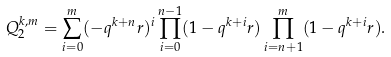Convert formula to latex. <formula><loc_0><loc_0><loc_500><loc_500>Q _ { 2 } ^ { k , m } = \sum _ { i = 0 } ^ { m } ( - q ^ { k + n } r ) ^ { i } \prod _ { i = 0 } ^ { n - 1 } ( 1 - q ^ { k + i } r ) \prod _ { i = n + 1 } ^ { m } ( 1 - q ^ { k + i } r ) .</formula> 